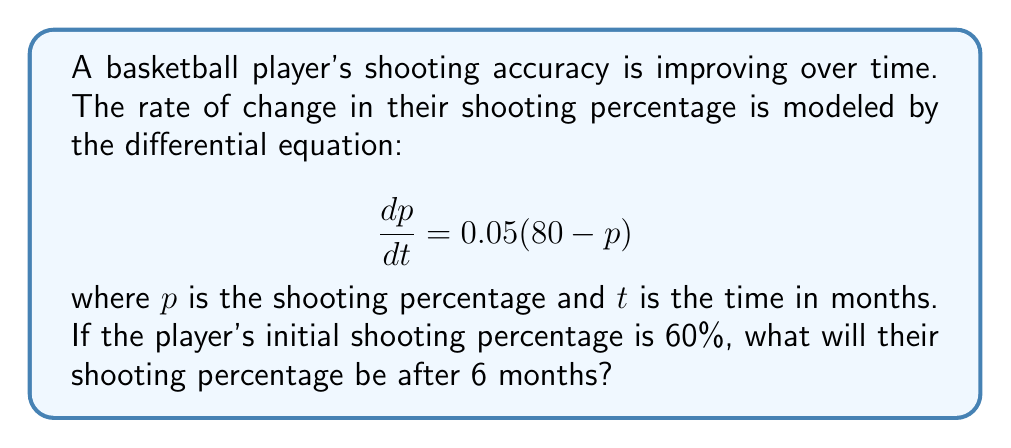Give your solution to this math problem. To solve this problem, we need to use the method for solving first-order linear differential equations.

1) First, we identify that this is a separable differential equation in the form:
   $$\frac{dp}{dt} = k(L - p)$$
   where $k = 0.05$ and $L = 80$ (the limiting value).

2) We can rewrite this as:
   $$\frac{dp}{80 - p} = 0.05dt$$

3) Integrating both sides:
   $$\int \frac{dp}{80 - p} = \int 0.05dt$$

4) This gives us:
   $$-\ln|80 - p| = 0.05t + C$$

5) Solving for $p$:
   $$80 - p = e^{-(0.05t + C)}$$
   $$p = 80 - Ae^{-0.05t}$$ where $A = e^{-C}$

6) Using the initial condition $p(0) = 60$, we can find $A$:
   $$60 = 80 - A$$
   $$A = 20$$

7) So our solution is:
   $$p = 80 - 20e^{-0.05t}$$

8) To find the shooting percentage after 6 months, we plug in $t = 6$:
   $$p(6) = 80 - 20e^{-0.05(6)}$$
   $$= 80 - 20e^{-0.3}$$
   $$\approx 74.10$$

Therefore, after 6 months, the player's shooting percentage will be approximately 74.10%.
Answer: 74.10% 